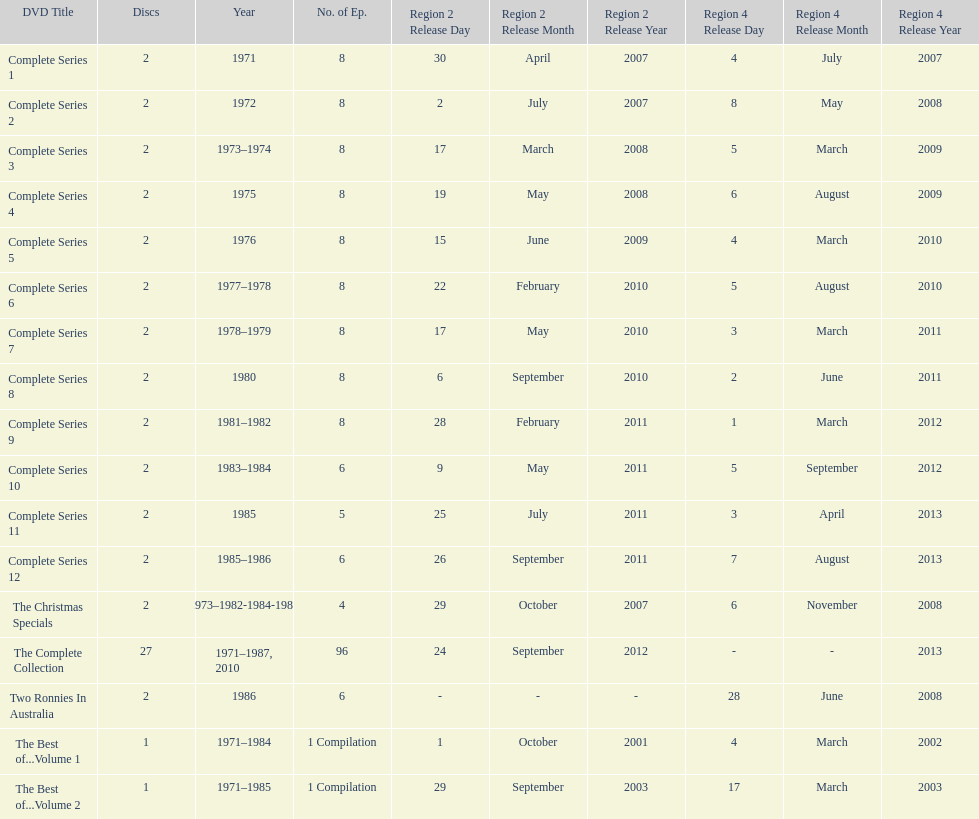What is the total of all dics listed in the table? 57. 